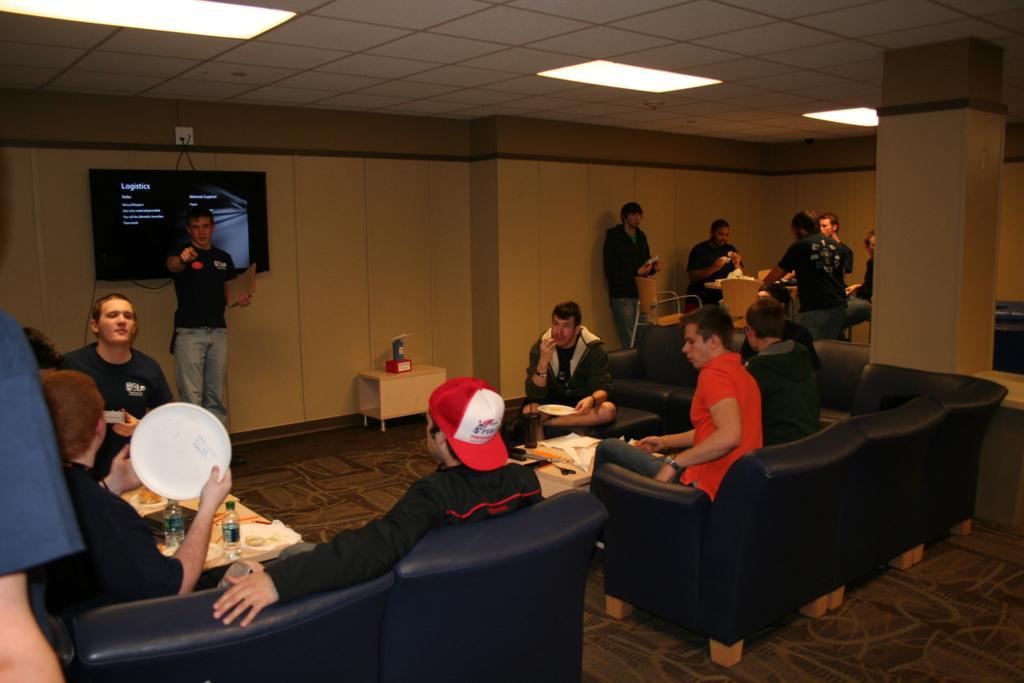Please provide a concise description of this image. This image is taken in a room. There are group of people sitting on chairs in the center. There are four people towards the right and four people towards the left. There is another person in the center. he is wearing a black t shirt, blue jeans and holding paper, behind him there is a television. In the left corner there is a man wearing black t shirt, holding a plate. besides him there is another person, he is wearing a black t shirt and a red cap. Towards the right there is a person wearing a orange t shirt and blue jeans. Towards the right corner of the room, there are group of people standing besides a table. To the right corner there is a pillar. In the top there is a ceiling with lights. 